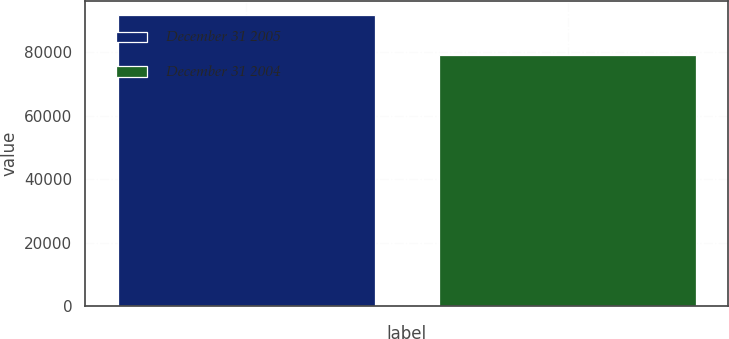Convert chart to OTSL. <chart><loc_0><loc_0><loc_500><loc_500><bar_chart><fcel>December 31 2005<fcel>December 31 2004<nl><fcel>91630<fcel>79111<nl></chart> 